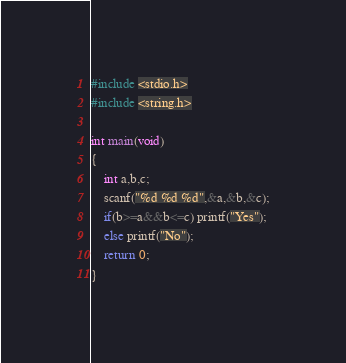<code> <loc_0><loc_0><loc_500><loc_500><_C_>#include <stdio.h>
#include <string.h>

int main(void)
{
    int a,b,c;
    scanf("%d %d %d",&a,&b,&c);
    if(b>=a&&b<=c) printf("Yes");
    else printf("No");
    return 0;
}
</code> 